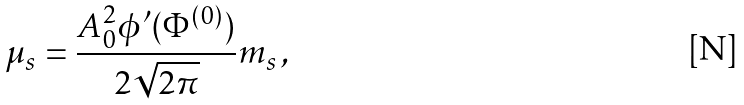Convert formula to latex. <formula><loc_0><loc_0><loc_500><loc_500>\mu _ { s } = \frac { A _ { 0 } ^ { 2 } \phi ^ { \prime } ( \Phi ^ { ( 0 ) } ) } { 2 \sqrt { 2 \pi } } m _ { s } \, ,</formula> 